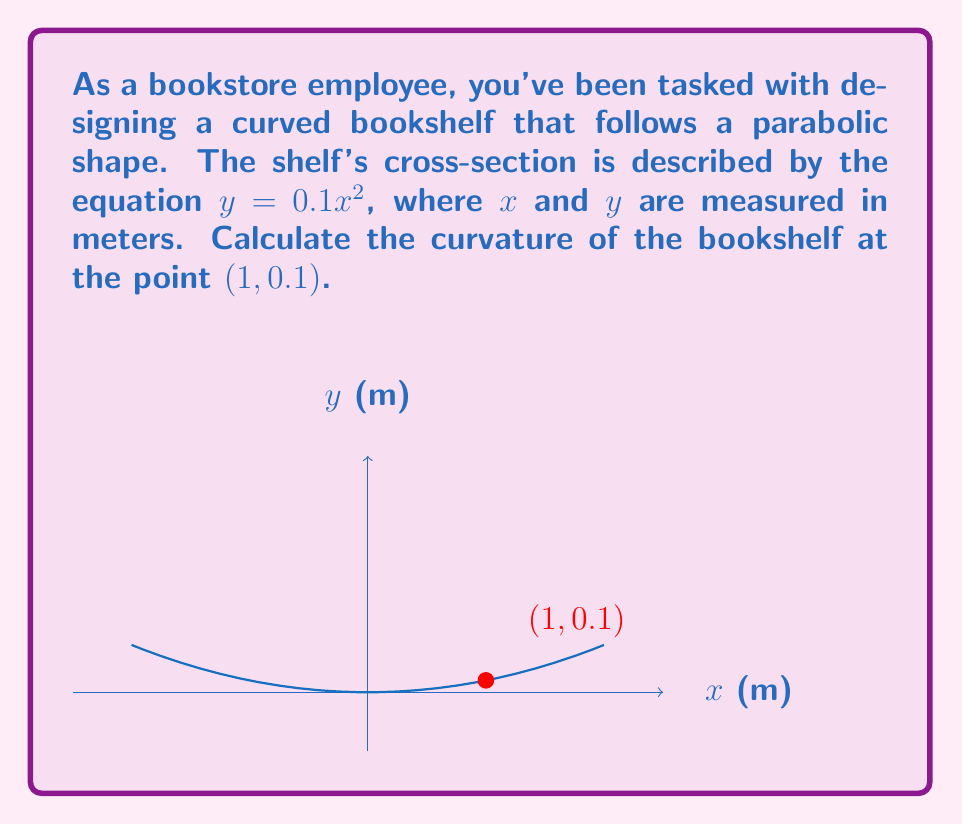Can you solve this math problem? To determine the curvature of the curved bookshelf at the given point, we'll follow these steps:

1) The curvature $\kappa$ of a curve $y = f(x)$ at any point is given by:

   $$\kappa = \frac{|f''(x)|}{(1 + [f'(x)]^2)^{3/2}}$$

2) First, we need to find $f'(x)$ and $f''(x)$:
   
   $f(x) = 0.1x^2$
   $f'(x) = 0.2x$
   $f''(x) = 0.2$

3) At the point (1, 0.1), $x = 1$. Let's calculate $f'(1)$:
   
   $f'(1) = 0.2(1) = 0.2$

4) Now we can substitute these values into the curvature formula:

   $$\kappa = \frac{|0.2|}{(1 + [0.2]^2)^{3/2}}$$

5) Simplify:
   $$\kappa = \frac{0.2}{(1 + 0.04)^{3/2}} = \frac{0.2}{1.04^{3/2}}$$

6) Calculate the final value:
   $$\kappa \approx 0.1923 \text{ m}^{-1}$$

This curvature value indicates how sharply the bookshelf curves at the point (1, 0.1).
Answer: $0.1923 \text{ m}^{-1}$ 